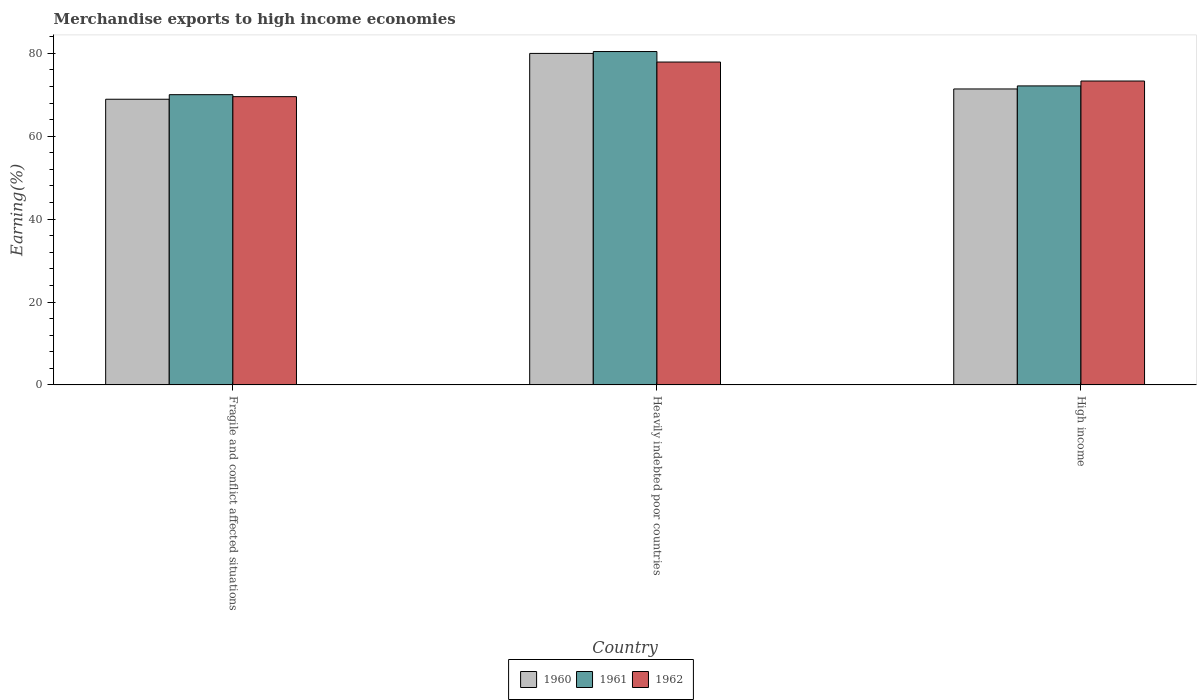How many groups of bars are there?
Offer a terse response. 3. Are the number of bars on each tick of the X-axis equal?
Give a very brief answer. Yes. How many bars are there on the 3rd tick from the right?
Keep it short and to the point. 3. What is the label of the 2nd group of bars from the left?
Your answer should be very brief. Heavily indebted poor countries. In how many cases, is the number of bars for a given country not equal to the number of legend labels?
Your response must be concise. 0. What is the percentage of amount earned from merchandise exports in 1962 in Fragile and conflict affected situations?
Offer a very short reply. 69.56. Across all countries, what is the maximum percentage of amount earned from merchandise exports in 1960?
Provide a short and direct response. 79.99. Across all countries, what is the minimum percentage of amount earned from merchandise exports in 1961?
Your answer should be very brief. 70.03. In which country was the percentage of amount earned from merchandise exports in 1960 maximum?
Make the answer very short. Heavily indebted poor countries. In which country was the percentage of amount earned from merchandise exports in 1961 minimum?
Provide a short and direct response. Fragile and conflict affected situations. What is the total percentage of amount earned from merchandise exports in 1960 in the graph?
Make the answer very short. 220.33. What is the difference between the percentage of amount earned from merchandise exports in 1962 in Fragile and conflict affected situations and that in High income?
Offer a terse response. -3.77. What is the difference between the percentage of amount earned from merchandise exports in 1961 in High income and the percentage of amount earned from merchandise exports in 1960 in Fragile and conflict affected situations?
Offer a terse response. 3.22. What is the average percentage of amount earned from merchandise exports in 1961 per country?
Provide a succinct answer. 74.21. What is the difference between the percentage of amount earned from merchandise exports of/in 1960 and percentage of amount earned from merchandise exports of/in 1961 in High income?
Provide a succinct answer. -0.74. In how many countries, is the percentage of amount earned from merchandise exports in 1962 greater than 64 %?
Provide a succinct answer. 3. What is the ratio of the percentage of amount earned from merchandise exports in 1962 in Fragile and conflict affected situations to that in Heavily indebted poor countries?
Your answer should be very brief. 0.89. Is the difference between the percentage of amount earned from merchandise exports in 1960 in Fragile and conflict affected situations and Heavily indebted poor countries greater than the difference between the percentage of amount earned from merchandise exports in 1961 in Fragile and conflict affected situations and Heavily indebted poor countries?
Provide a short and direct response. No. What is the difference between the highest and the second highest percentage of amount earned from merchandise exports in 1962?
Your answer should be very brief. 3.77. What is the difference between the highest and the lowest percentage of amount earned from merchandise exports in 1961?
Offer a terse response. 10.41. In how many countries, is the percentage of amount earned from merchandise exports in 1960 greater than the average percentage of amount earned from merchandise exports in 1960 taken over all countries?
Your answer should be compact. 1. Is the sum of the percentage of amount earned from merchandise exports in 1961 in Fragile and conflict affected situations and Heavily indebted poor countries greater than the maximum percentage of amount earned from merchandise exports in 1962 across all countries?
Ensure brevity in your answer.  Yes. What does the 1st bar from the right in Fragile and conflict affected situations represents?
Your answer should be very brief. 1962. Is it the case that in every country, the sum of the percentage of amount earned from merchandise exports in 1962 and percentage of amount earned from merchandise exports in 1960 is greater than the percentage of amount earned from merchandise exports in 1961?
Offer a terse response. Yes. Are all the bars in the graph horizontal?
Offer a very short reply. No. What is the difference between two consecutive major ticks on the Y-axis?
Provide a short and direct response. 20. Are the values on the major ticks of Y-axis written in scientific E-notation?
Offer a very short reply. No. Where does the legend appear in the graph?
Your answer should be very brief. Bottom center. How many legend labels are there?
Your answer should be very brief. 3. How are the legend labels stacked?
Keep it short and to the point. Horizontal. What is the title of the graph?
Offer a very short reply. Merchandise exports to high income economies. What is the label or title of the X-axis?
Provide a short and direct response. Country. What is the label or title of the Y-axis?
Keep it short and to the point. Earning(%). What is the Earning(%) of 1960 in Fragile and conflict affected situations?
Your response must be concise. 68.93. What is the Earning(%) of 1961 in Fragile and conflict affected situations?
Your answer should be very brief. 70.03. What is the Earning(%) of 1962 in Fragile and conflict affected situations?
Your response must be concise. 69.56. What is the Earning(%) of 1960 in Heavily indebted poor countries?
Your response must be concise. 79.99. What is the Earning(%) in 1961 in Heavily indebted poor countries?
Ensure brevity in your answer.  80.44. What is the Earning(%) in 1962 in Heavily indebted poor countries?
Your answer should be very brief. 77.91. What is the Earning(%) in 1960 in High income?
Give a very brief answer. 71.41. What is the Earning(%) in 1961 in High income?
Provide a short and direct response. 72.15. What is the Earning(%) of 1962 in High income?
Offer a very short reply. 73.33. Across all countries, what is the maximum Earning(%) of 1960?
Your answer should be very brief. 79.99. Across all countries, what is the maximum Earning(%) of 1961?
Provide a short and direct response. 80.44. Across all countries, what is the maximum Earning(%) in 1962?
Provide a short and direct response. 77.91. Across all countries, what is the minimum Earning(%) in 1960?
Keep it short and to the point. 68.93. Across all countries, what is the minimum Earning(%) in 1961?
Provide a short and direct response. 70.03. Across all countries, what is the minimum Earning(%) of 1962?
Your response must be concise. 69.56. What is the total Earning(%) of 1960 in the graph?
Ensure brevity in your answer.  220.33. What is the total Earning(%) in 1961 in the graph?
Give a very brief answer. 222.62. What is the total Earning(%) in 1962 in the graph?
Provide a short and direct response. 220.79. What is the difference between the Earning(%) in 1960 in Fragile and conflict affected situations and that in Heavily indebted poor countries?
Give a very brief answer. -11.06. What is the difference between the Earning(%) of 1961 in Fragile and conflict affected situations and that in Heavily indebted poor countries?
Give a very brief answer. -10.41. What is the difference between the Earning(%) of 1962 in Fragile and conflict affected situations and that in Heavily indebted poor countries?
Keep it short and to the point. -8.35. What is the difference between the Earning(%) in 1960 in Fragile and conflict affected situations and that in High income?
Make the answer very short. -2.48. What is the difference between the Earning(%) in 1961 in Fragile and conflict affected situations and that in High income?
Provide a short and direct response. -2.12. What is the difference between the Earning(%) in 1962 in Fragile and conflict affected situations and that in High income?
Give a very brief answer. -3.77. What is the difference between the Earning(%) of 1960 in Heavily indebted poor countries and that in High income?
Your answer should be compact. 8.58. What is the difference between the Earning(%) of 1961 in Heavily indebted poor countries and that in High income?
Give a very brief answer. 8.29. What is the difference between the Earning(%) in 1962 in Heavily indebted poor countries and that in High income?
Provide a short and direct response. 4.58. What is the difference between the Earning(%) of 1960 in Fragile and conflict affected situations and the Earning(%) of 1961 in Heavily indebted poor countries?
Offer a very short reply. -11.51. What is the difference between the Earning(%) in 1960 in Fragile and conflict affected situations and the Earning(%) in 1962 in Heavily indebted poor countries?
Your answer should be very brief. -8.98. What is the difference between the Earning(%) of 1961 in Fragile and conflict affected situations and the Earning(%) of 1962 in Heavily indebted poor countries?
Ensure brevity in your answer.  -7.87. What is the difference between the Earning(%) of 1960 in Fragile and conflict affected situations and the Earning(%) of 1961 in High income?
Ensure brevity in your answer.  -3.22. What is the difference between the Earning(%) of 1960 in Fragile and conflict affected situations and the Earning(%) of 1962 in High income?
Your answer should be very brief. -4.4. What is the difference between the Earning(%) in 1961 in Fragile and conflict affected situations and the Earning(%) in 1962 in High income?
Offer a terse response. -3.29. What is the difference between the Earning(%) in 1960 in Heavily indebted poor countries and the Earning(%) in 1961 in High income?
Provide a succinct answer. 7.84. What is the difference between the Earning(%) of 1960 in Heavily indebted poor countries and the Earning(%) of 1962 in High income?
Offer a terse response. 6.66. What is the difference between the Earning(%) of 1961 in Heavily indebted poor countries and the Earning(%) of 1962 in High income?
Make the answer very short. 7.11. What is the average Earning(%) of 1960 per country?
Your answer should be very brief. 73.44. What is the average Earning(%) in 1961 per country?
Ensure brevity in your answer.  74.21. What is the average Earning(%) of 1962 per country?
Your response must be concise. 73.6. What is the difference between the Earning(%) of 1960 and Earning(%) of 1961 in Fragile and conflict affected situations?
Your answer should be very brief. -1.1. What is the difference between the Earning(%) in 1960 and Earning(%) in 1962 in Fragile and conflict affected situations?
Your response must be concise. -0.63. What is the difference between the Earning(%) in 1961 and Earning(%) in 1962 in Fragile and conflict affected situations?
Offer a very short reply. 0.48. What is the difference between the Earning(%) in 1960 and Earning(%) in 1961 in Heavily indebted poor countries?
Give a very brief answer. -0.45. What is the difference between the Earning(%) in 1960 and Earning(%) in 1962 in Heavily indebted poor countries?
Keep it short and to the point. 2.08. What is the difference between the Earning(%) in 1961 and Earning(%) in 1962 in Heavily indebted poor countries?
Provide a short and direct response. 2.53. What is the difference between the Earning(%) in 1960 and Earning(%) in 1961 in High income?
Your answer should be compact. -0.74. What is the difference between the Earning(%) of 1960 and Earning(%) of 1962 in High income?
Your answer should be very brief. -1.92. What is the difference between the Earning(%) in 1961 and Earning(%) in 1962 in High income?
Provide a short and direct response. -1.18. What is the ratio of the Earning(%) of 1960 in Fragile and conflict affected situations to that in Heavily indebted poor countries?
Provide a short and direct response. 0.86. What is the ratio of the Earning(%) in 1961 in Fragile and conflict affected situations to that in Heavily indebted poor countries?
Your answer should be very brief. 0.87. What is the ratio of the Earning(%) in 1962 in Fragile and conflict affected situations to that in Heavily indebted poor countries?
Make the answer very short. 0.89. What is the ratio of the Earning(%) in 1960 in Fragile and conflict affected situations to that in High income?
Your answer should be very brief. 0.97. What is the ratio of the Earning(%) in 1961 in Fragile and conflict affected situations to that in High income?
Keep it short and to the point. 0.97. What is the ratio of the Earning(%) in 1962 in Fragile and conflict affected situations to that in High income?
Provide a short and direct response. 0.95. What is the ratio of the Earning(%) of 1960 in Heavily indebted poor countries to that in High income?
Offer a very short reply. 1.12. What is the ratio of the Earning(%) of 1961 in Heavily indebted poor countries to that in High income?
Offer a terse response. 1.11. What is the difference between the highest and the second highest Earning(%) of 1960?
Your answer should be compact. 8.58. What is the difference between the highest and the second highest Earning(%) of 1961?
Keep it short and to the point. 8.29. What is the difference between the highest and the second highest Earning(%) in 1962?
Ensure brevity in your answer.  4.58. What is the difference between the highest and the lowest Earning(%) in 1960?
Make the answer very short. 11.06. What is the difference between the highest and the lowest Earning(%) in 1961?
Provide a short and direct response. 10.41. What is the difference between the highest and the lowest Earning(%) of 1962?
Your response must be concise. 8.35. 